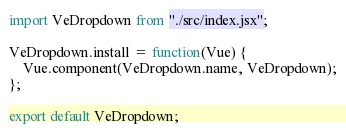<code> <loc_0><loc_0><loc_500><loc_500><_JavaScript_>import VeDropdown from "./src/index.jsx";

VeDropdown.install = function(Vue) {
    Vue.component(VeDropdown.name, VeDropdown);
};

export default VeDropdown;
</code> 